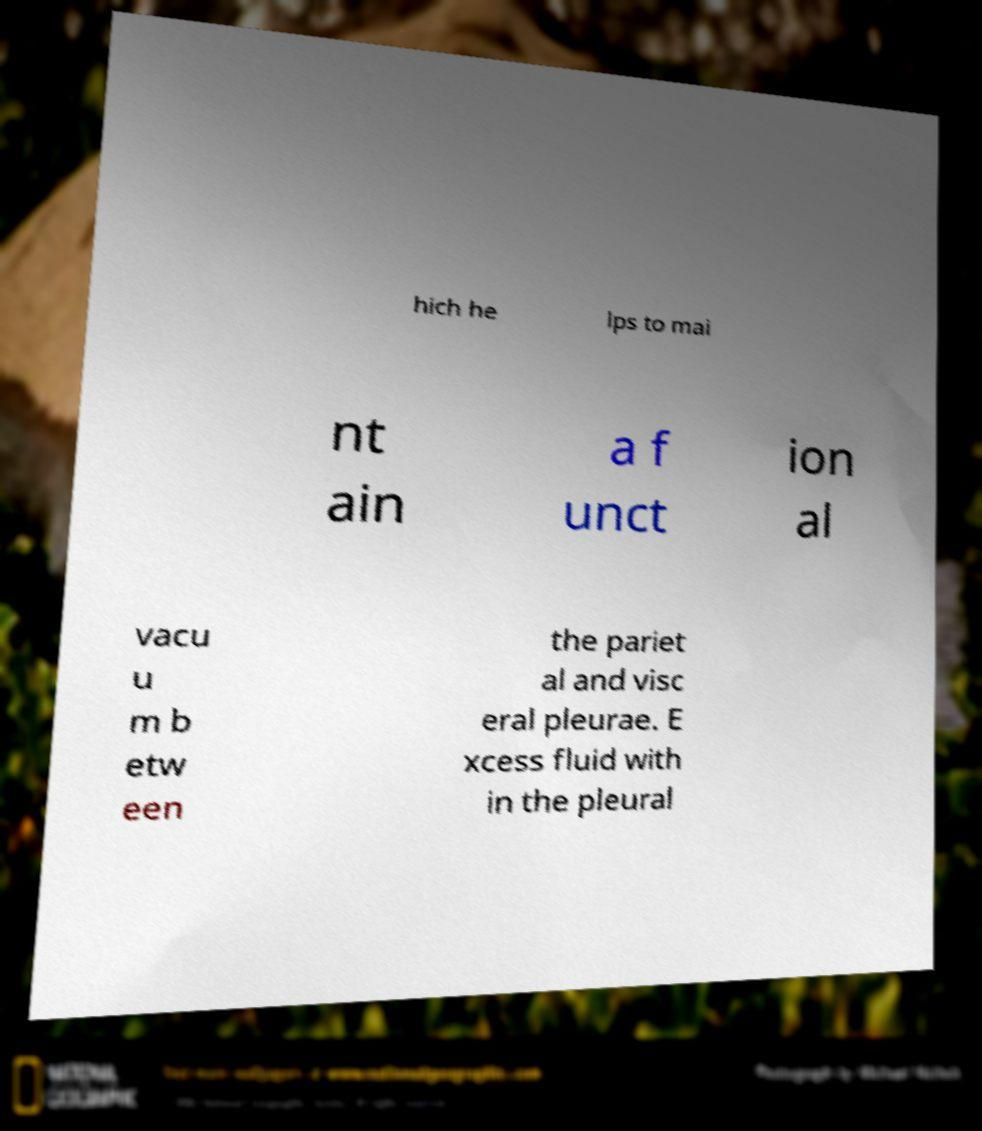For documentation purposes, I need the text within this image transcribed. Could you provide that? hich he lps to mai nt ain a f unct ion al vacu u m b etw een the pariet al and visc eral pleurae. E xcess fluid with in the pleural 